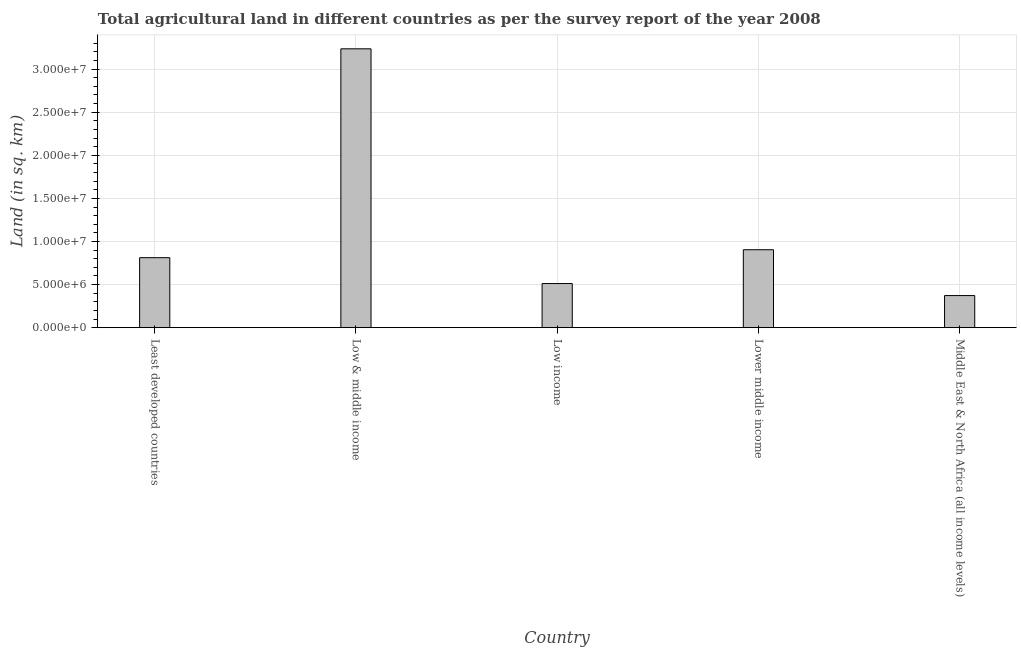What is the title of the graph?
Give a very brief answer. Total agricultural land in different countries as per the survey report of the year 2008. What is the label or title of the X-axis?
Your answer should be very brief. Country. What is the label or title of the Y-axis?
Make the answer very short. Land (in sq. km). What is the agricultural land in Lower middle income?
Your response must be concise. 9.04e+06. Across all countries, what is the maximum agricultural land?
Your answer should be very brief. 3.24e+07. Across all countries, what is the minimum agricultural land?
Provide a succinct answer. 3.72e+06. In which country was the agricultural land maximum?
Offer a very short reply. Low & middle income. In which country was the agricultural land minimum?
Ensure brevity in your answer.  Middle East & North Africa (all income levels). What is the sum of the agricultural land?
Give a very brief answer. 5.84e+07. What is the difference between the agricultural land in Least developed countries and Middle East & North Africa (all income levels)?
Your answer should be very brief. 4.40e+06. What is the average agricultural land per country?
Offer a very short reply. 1.17e+07. What is the median agricultural land?
Provide a short and direct response. 8.12e+06. In how many countries, is the agricultural land greater than 8000000 sq. km?
Provide a succinct answer. 3. What is the ratio of the agricultural land in Least developed countries to that in Lower middle income?
Give a very brief answer. 0.9. Is the agricultural land in Least developed countries less than that in Low & middle income?
Ensure brevity in your answer.  Yes. Is the difference between the agricultural land in Low & middle income and Low income greater than the difference between any two countries?
Offer a very short reply. No. What is the difference between the highest and the second highest agricultural land?
Ensure brevity in your answer.  2.33e+07. Is the sum of the agricultural land in Low & middle income and Middle East & North Africa (all income levels) greater than the maximum agricultural land across all countries?
Your answer should be compact. Yes. What is the difference between the highest and the lowest agricultural land?
Provide a short and direct response. 2.86e+07. How many countries are there in the graph?
Provide a short and direct response. 5. What is the difference between two consecutive major ticks on the Y-axis?
Give a very brief answer. 5.00e+06. Are the values on the major ticks of Y-axis written in scientific E-notation?
Your response must be concise. Yes. What is the Land (in sq. km) of Least developed countries?
Provide a succinct answer. 8.12e+06. What is the Land (in sq. km) of Low & middle income?
Your response must be concise. 3.24e+07. What is the Land (in sq. km) of Low income?
Offer a terse response. 5.12e+06. What is the Land (in sq. km) in Lower middle income?
Your response must be concise. 9.04e+06. What is the Land (in sq. km) in Middle East & North Africa (all income levels)?
Your answer should be very brief. 3.72e+06. What is the difference between the Land (in sq. km) in Least developed countries and Low & middle income?
Ensure brevity in your answer.  -2.42e+07. What is the difference between the Land (in sq. km) in Least developed countries and Low income?
Make the answer very short. 3.00e+06. What is the difference between the Land (in sq. km) in Least developed countries and Lower middle income?
Provide a short and direct response. -9.23e+05. What is the difference between the Land (in sq. km) in Least developed countries and Middle East & North Africa (all income levels)?
Your answer should be very brief. 4.40e+06. What is the difference between the Land (in sq. km) in Low & middle income and Low income?
Offer a terse response. 2.72e+07. What is the difference between the Land (in sq. km) in Low & middle income and Lower middle income?
Ensure brevity in your answer.  2.33e+07. What is the difference between the Land (in sq. km) in Low & middle income and Middle East & North Africa (all income levels)?
Make the answer very short. 2.86e+07. What is the difference between the Land (in sq. km) in Low income and Lower middle income?
Offer a very short reply. -3.92e+06. What is the difference between the Land (in sq. km) in Low income and Middle East & North Africa (all income levels)?
Offer a very short reply. 1.39e+06. What is the difference between the Land (in sq. km) in Lower middle income and Middle East & North Africa (all income levels)?
Provide a succinct answer. 5.32e+06. What is the ratio of the Land (in sq. km) in Least developed countries to that in Low & middle income?
Your response must be concise. 0.25. What is the ratio of the Land (in sq. km) in Least developed countries to that in Low income?
Your answer should be very brief. 1.59. What is the ratio of the Land (in sq. km) in Least developed countries to that in Lower middle income?
Give a very brief answer. 0.9. What is the ratio of the Land (in sq. km) in Least developed countries to that in Middle East & North Africa (all income levels)?
Keep it short and to the point. 2.18. What is the ratio of the Land (in sq. km) in Low & middle income to that in Low income?
Provide a short and direct response. 6.32. What is the ratio of the Land (in sq. km) in Low & middle income to that in Lower middle income?
Your answer should be very brief. 3.58. What is the ratio of the Land (in sq. km) in Low & middle income to that in Middle East & North Africa (all income levels)?
Offer a very short reply. 8.69. What is the ratio of the Land (in sq. km) in Low income to that in Lower middle income?
Ensure brevity in your answer.  0.57. What is the ratio of the Land (in sq. km) in Low income to that in Middle East & North Africa (all income levels)?
Provide a short and direct response. 1.37. What is the ratio of the Land (in sq. km) in Lower middle income to that in Middle East & North Africa (all income levels)?
Make the answer very short. 2.43. 